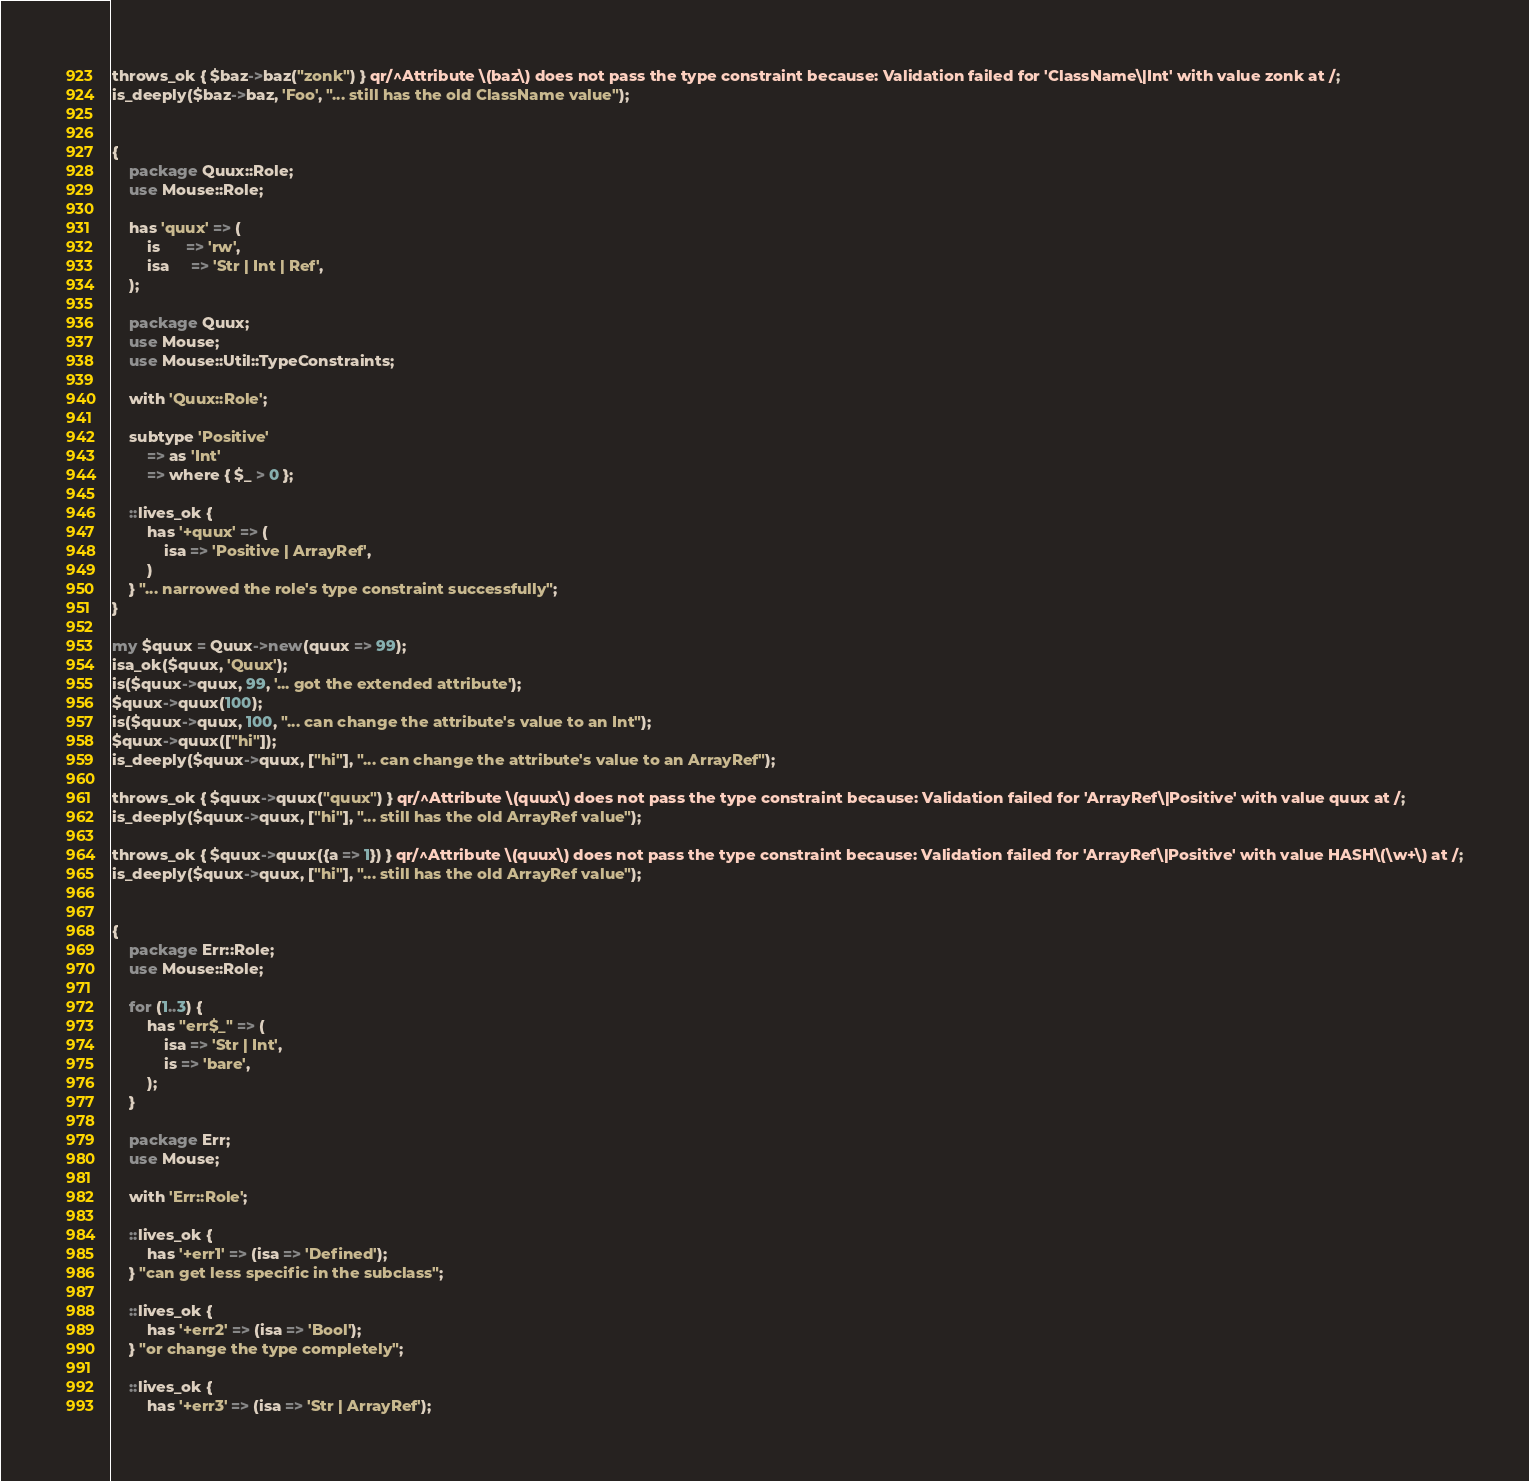<code> <loc_0><loc_0><loc_500><loc_500><_Perl_>throws_ok { $baz->baz("zonk") } qr/^Attribute \(baz\) does not pass the type constraint because: Validation failed for 'ClassName\|Int' with value zonk at /;
is_deeply($baz->baz, 'Foo', "... still has the old ClassName value");


{
    package Quux::Role;
    use Mouse::Role;

    has 'quux' => (
        is      => 'rw',
        isa     => 'Str | Int | Ref',
    );

    package Quux;
    use Mouse;
    use Mouse::Util::TypeConstraints;

    with 'Quux::Role';

    subtype 'Positive'
        => as 'Int'
        => where { $_ > 0 };

    ::lives_ok {
        has '+quux' => (
            isa => 'Positive | ArrayRef',
        )
    } "... narrowed the role's type constraint successfully";
}

my $quux = Quux->new(quux => 99);
isa_ok($quux, 'Quux');
is($quux->quux, 99, '... got the extended attribute');
$quux->quux(100);
is($quux->quux, 100, "... can change the attribute's value to an Int");
$quux->quux(["hi"]);
is_deeply($quux->quux, ["hi"], "... can change the attribute's value to an ArrayRef");

throws_ok { $quux->quux("quux") } qr/^Attribute \(quux\) does not pass the type constraint because: Validation failed for 'ArrayRef\|Positive' with value quux at /;
is_deeply($quux->quux, ["hi"], "... still has the old ArrayRef value");

throws_ok { $quux->quux({a => 1}) } qr/^Attribute \(quux\) does not pass the type constraint because: Validation failed for 'ArrayRef\|Positive' with value HASH\(\w+\) at /;
is_deeply($quux->quux, ["hi"], "... still has the old ArrayRef value");


{
    package Err::Role;
    use Mouse::Role;

    for (1..3) {
        has "err$_" => (
            isa => 'Str | Int',
            is => 'bare',
        );
    }

    package Err;
    use Mouse;

    with 'Err::Role';

    ::lives_ok {
        has '+err1' => (isa => 'Defined');
    } "can get less specific in the subclass";

    ::lives_ok {
        has '+err2' => (isa => 'Bool');
    } "or change the type completely";

    ::lives_ok {
        has '+err3' => (isa => 'Str | ArrayRef');</code> 